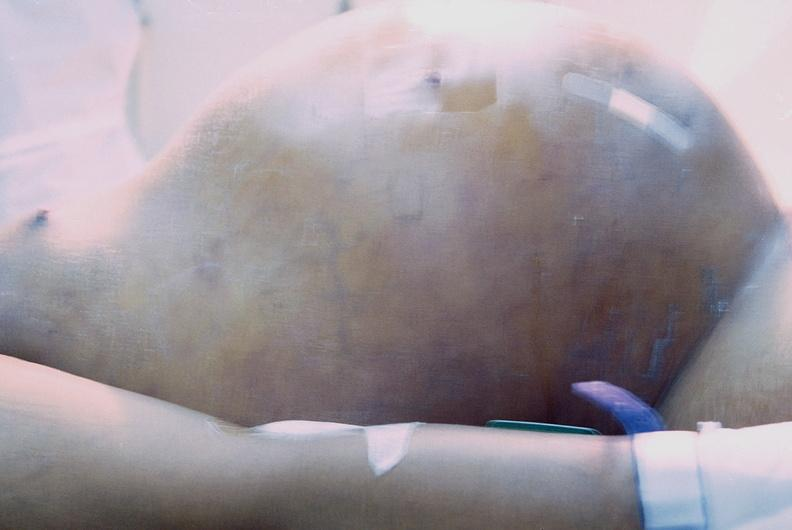does omentum show ascites?
Answer the question using a single word or phrase. No 